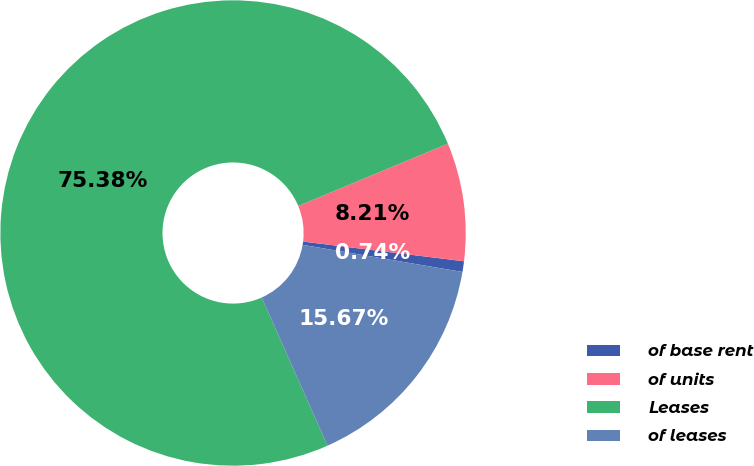Convert chart to OTSL. <chart><loc_0><loc_0><loc_500><loc_500><pie_chart><fcel>of base rent<fcel>of units<fcel>Leases<fcel>of leases<nl><fcel>0.74%<fcel>8.21%<fcel>75.38%<fcel>15.67%<nl></chart> 